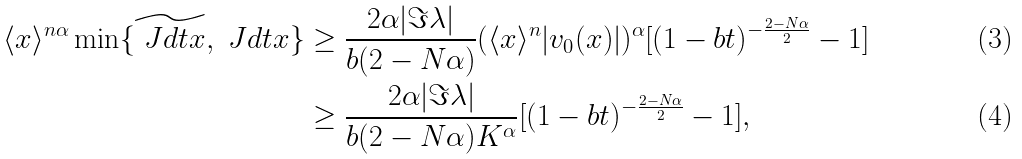Convert formula to latex. <formula><loc_0><loc_0><loc_500><loc_500>\langle x \rangle ^ { n \alpha } \min \{ \widetilde { \ J d t x } , \ J d t x \} & \geq \frac { 2 \alpha | \Im \lambda | } { b ( 2 - N \alpha ) } ( \langle x \rangle ^ { n } | v _ { 0 } ( x ) | ) ^ { \alpha } [ ( 1 - b t ) ^ { - \frac { 2 - N \alpha } { 2 } } - 1 ] \\ & \geq \frac { 2 \alpha | \Im \lambda | } { b ( 2 - N \alpha ) K ^ { \alpha } } [ ( 1 - b t ) ^ { - \frac { 2 - N \alpha } { 2 } } - 1 ] ,</formula> 